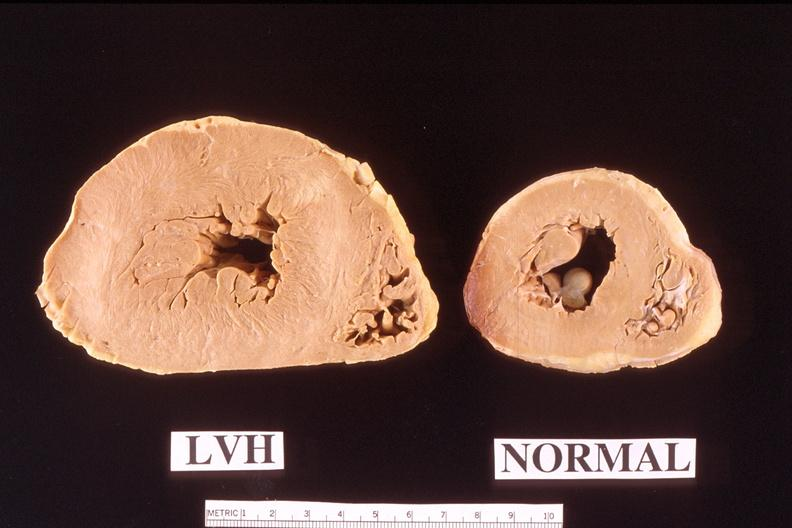s cardiovascular present?
Answer the question using a single word or phrase. Yes 